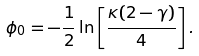Convert formula to latex. <formula><loc_0><loc_0><loc_500><loc_500>\phi _ { 0 } = - \frac { 1 } { 2 } \ln \left [ \frac { \kappa ( 2 - \gamma ) } { 4 } \right ] .</formula> 